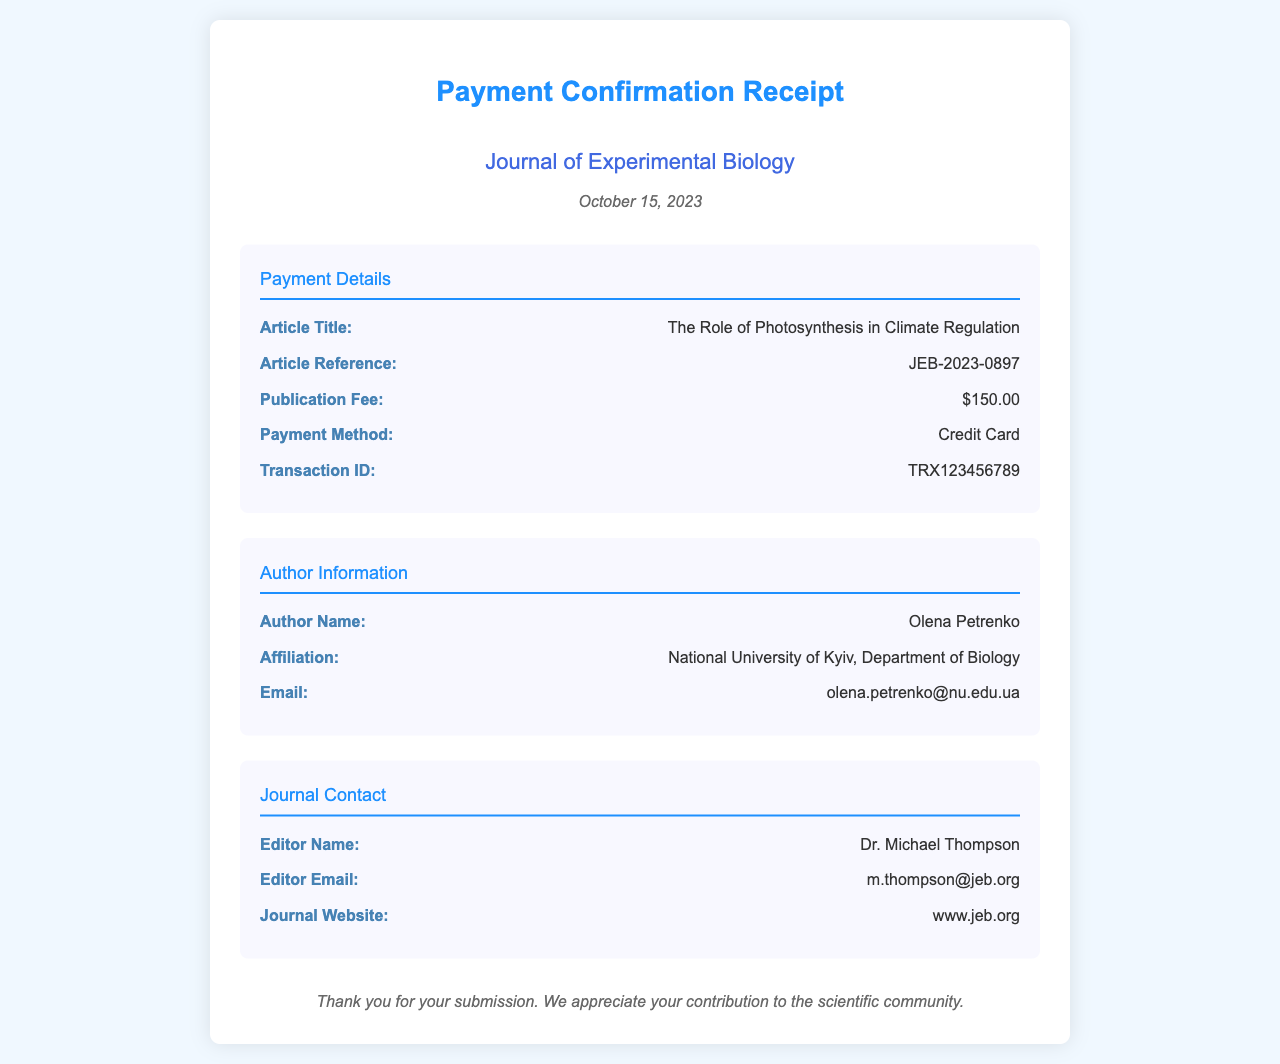What is the journal name? The journal name is stated in the header of the receipt as "Journal of Experimental Biology."
Answer: Journal of Experimental Biology What is the article reference? The article reference can be found in the payment details section, specified as "JEB-2023-0897."
Answer: JEB-2023-0897 What is the payment method used? The payment method is listed in the payment details section and is "Credit Card."
Answer: Credit Card Who is the author of the article? The author's name is provided in the author information section as "Olena Petrenko."
Answer: Olena Petrenko What is the publication fee? The publication fee is mentioned in the payment details section as "$150.00."
Answer: $150.00 What date was the payment confirmation issued? The date is found in the header of the receipt, which states "October 15, 2023."
Answer: October 15, 2023 What is the transaction ID? The transaction ID is specified in the payment details section as "TRX123456789."
Answer: TRX123456789 What is the email address of the author? The author's email address is given in the author information section as "olena.petrenko@nu.edu.ua."
Answer: olena.petrenko@nu.edu.ua Who is the editor of the journal? The editor's name is provided in the journal contact section as "Dr. Michael Thompson."
Answer: Dr. Michael Thompson 